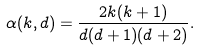<formula> <loc_0><loc_0><loc_500><loc_500>\alpha ( { k , d } ) = \frac { 2 k ( k + 1 ) } { d ( d + 1 ) ( d + 2 ) } .</formula> 